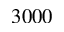Convert formula to latex. <formula><loc_0><loc_0><loc_500><loc_500>3 0 0 0</formula> 